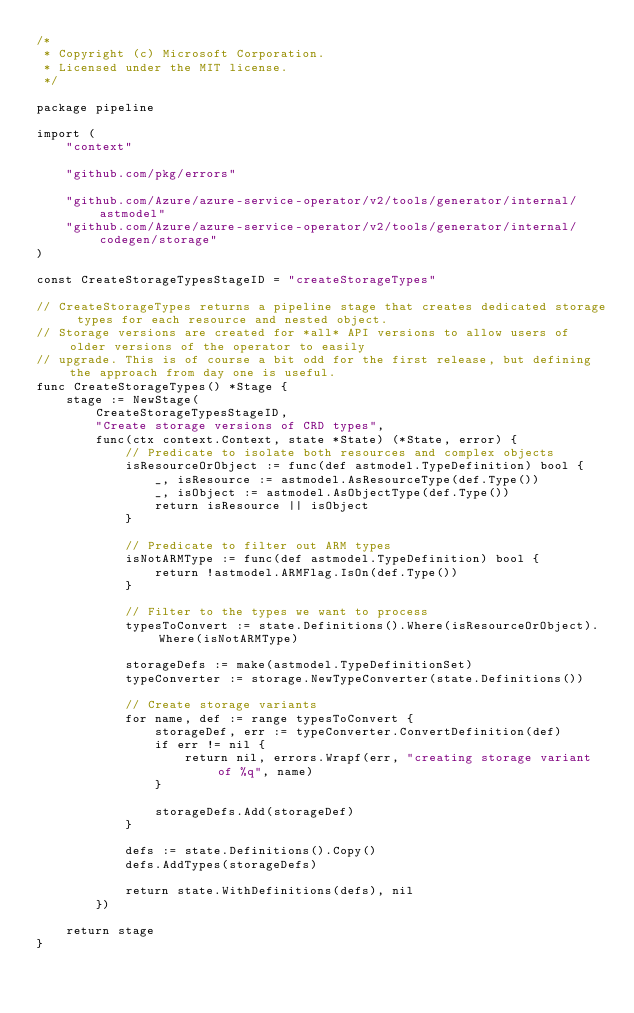Convert code to text. <code><loc_0><loc_0><loc_500><loc_500><_Go_>/*
 * Copyright (c) Microsoft Corporation.
 * Licensed under the MIT license.
 */

package pipeline

import (
	"context"

	"github.com/pkg/errors"

	"github.com/Azure/azure-service-operator/v2/tools/generator/internal/astmodel"
	"github.com/Azure/azure-service-operator/v2/tools/generator/internal/codegen/storage"
)

const CreateStorageTypesStageID = "createStorageTypes"

// CreateStorageTypes returns a pipeline stage that creates dedicated storage types for each resource and nested object.
// Storage versions are created for *all* API versions to allow users of older versions of the operator to easily
// upgrade. This is of course a bit odd for the first release, but defining the approach from day one is useful.
func CreateStorageTypes() *Stage {
	stage := NewStage(
		CreateStorageTypesStageID,
		"Create storage versions of CRD types",
		func(ctx context.Context, state *State) (*State, error) {
			// Predicate to isolate both resources and complex objects
			isResourceOrObject := func(def astmodel.TypeDefinition) bool {
				_, isResource := astmodel.AsResourceType(def.Type())
				_, isObject := astmodel.AsObjectType(def.Type())
				return isResource || isObject
			}

			// Predicate to filter out ARM types
			isNotARMType := func(def astmodel.TypeDefinition) bool {
				return !astmodel.ARMFlag.IsOn(def.Type())
			}

			// Filter to the types we want to process
			typesToConvert := state.Definitions().Where(isResourceOrObject).Where(isNotARMType)

			storageDefs := make(astmodel.TypeDefinitionSet)
			typeConverter := storage.NewTypeConverter(state.Definitions())

			// Create storage variants
			for name, def := range typesToConvert {
				storageDef, err := typeConverter.ConvertDefinition(def)
				if err != nil {
					return nil, errors.Wrapf(err, "creating storage variant of %q", name)
				}

				storageDefs.Add(storageDef)
			}

			defs := state.Definitions().Copy()
			defs.AddTypes(storageDefs)

			return state.WithDefinitions(defs), nil
		})

	return stage
}
</code> 